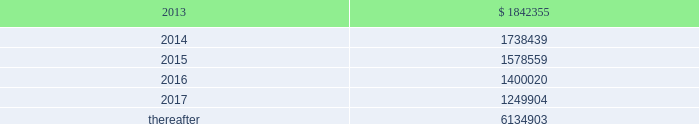Vornado realty trust notes to consolidated financial statements ( continued ) 20 .
Leases as lessor : we lease space to tenants under operating leases .
Most of the leases provide for the payment of fixed base rentals payable monthly in advance .
Office building leases generally require the tenants to reimburse us for operating costs and real estate taxes above their base year costs .
Shopping center leases provide for pass-through to tenants the tenant 2019s share of real estate taxes , insurance and maintenance .
Shopping center leases also provide for the payment by the lessee of additional rent based on a percentage of the tenants 2019 sales .
As of december 31 , 2012 , future base rental revenue under non-cancelable operating leases , excluding rents for leases with an original term of less than one year and rents resulting from the exercise of renewal options , are as follows : ( amounts in thousands ) year ending december 31: .
These amounts do not include percentage rentals based on tenants 2019 sales .
These percentage rents approximated $ 8466000 , $ 7995000 and $ 7339000 , for the years ended december 31 , 2012 , 2011 and 2010 , respectively .
None of our tenants accounted for more than 10% ( 10 % ) of total revenues in any of the years ended december 31 , 2012 , 2011 and 2010 .
Former bradlees locations pursuant to a master agreement and guaranty , dated may 1 , 1992 , we were due $ 5000000 of annual rent from stop & shop which was allocated to certain bradlees former locations .
On december 31 , 2002 , prior to the expiration of the leases to which the additional rent was allocated , we reallocated this rent to other former bradlees leases also guaranteed by stop & shop .
Stop & shop contested our right to reallocate the rent .
On november 7 , 2011 , the court determined that we had a continuing right to allocate the annual rent to unexpired leases covered by the master agreement and guaranty and directed entry of a judgment in our favor ordering stop & shop to pay us the unpaid annual rent .
At december 31 , 2012 , we had a $ 47900000 receivable from stop and shop , which is included as a component of 201ctenant and other receivables 201d on our consolidated balance sheet .
On february 6 , 2013 , we received $ 124000000 pursuant to a settlement agreement with stop & shop ( see note 22 2013 commitments and contingencies 2013 litigation ) . .
For future base rental revenue under non-cancelable operating leases , excluding rents for leases with an original term of less than one year and rents resulting from the exercise of renewal options , in thousands , what was the change between 2016 and 2017? 
Computations: (1400020 - 1249904)
Answer: 150116.0. 